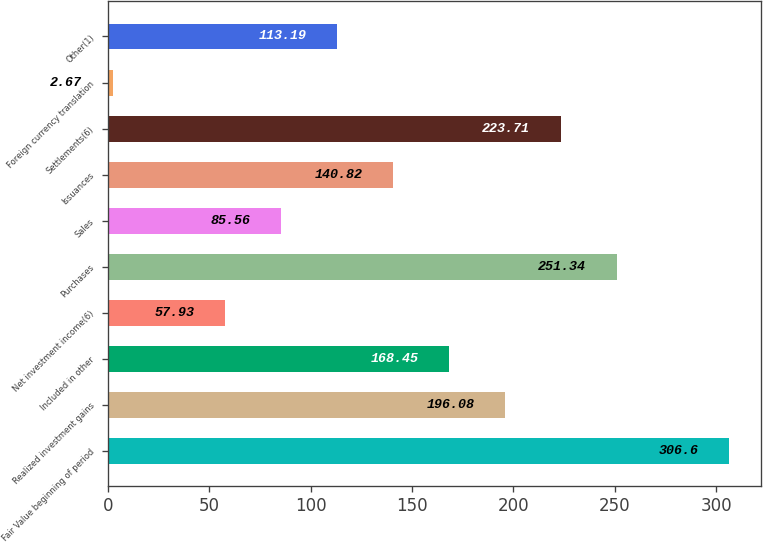Convert chart to OTSL. <chart><loc_0><loc_0><loc_500><loc_500><bar_chart><fcel>Fair Value beginning of period<fcel>Realized investment gains<fcel>Included in other<fcel>Net investment income(6)<fcel>Purchases<fcel>Sales<fcel>Issuances<fcel>Settlements(6)<fcel>Foreign currency translation<fcel>Other(1)<nl><fcel>306.6<fcel>196.08<fcel>168.45<fcel>57.93<fcel>251.34<fcel>85.56<fcel>140.82<fcel>223.71<fcel>2.67<fcel>113.19<nl></chart> 